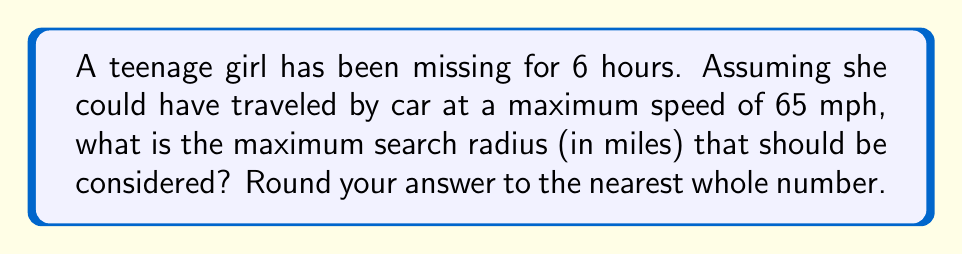Could you help me with this problem? Let's approach this step-by-step:

1) First, we need to understand the relationship between distance, speed, and time:
   $$\text{Distance} = \text{Speed} \times \text{Time}$$

2) We are given:
   - Time elapsed: 6 hours
   - Maximum speed: 65 mph

3) Plugging these values into our equation:
   $$\text{Maximum Distance} = 65 \text{ mph} \times 6 \text{ hours}$$

4) Calculating:
   $$\text{Maximum Distance} = 390 \text{ miles}$$

5) This distance represents the radius of our search area.

6) Rounding to the nearest whole number:
   $$390 \text{ miles} \approx 390 \text{ miles}$$

Therefore, the maximum search radius should be 390 miles.
Answer: 390 miles 